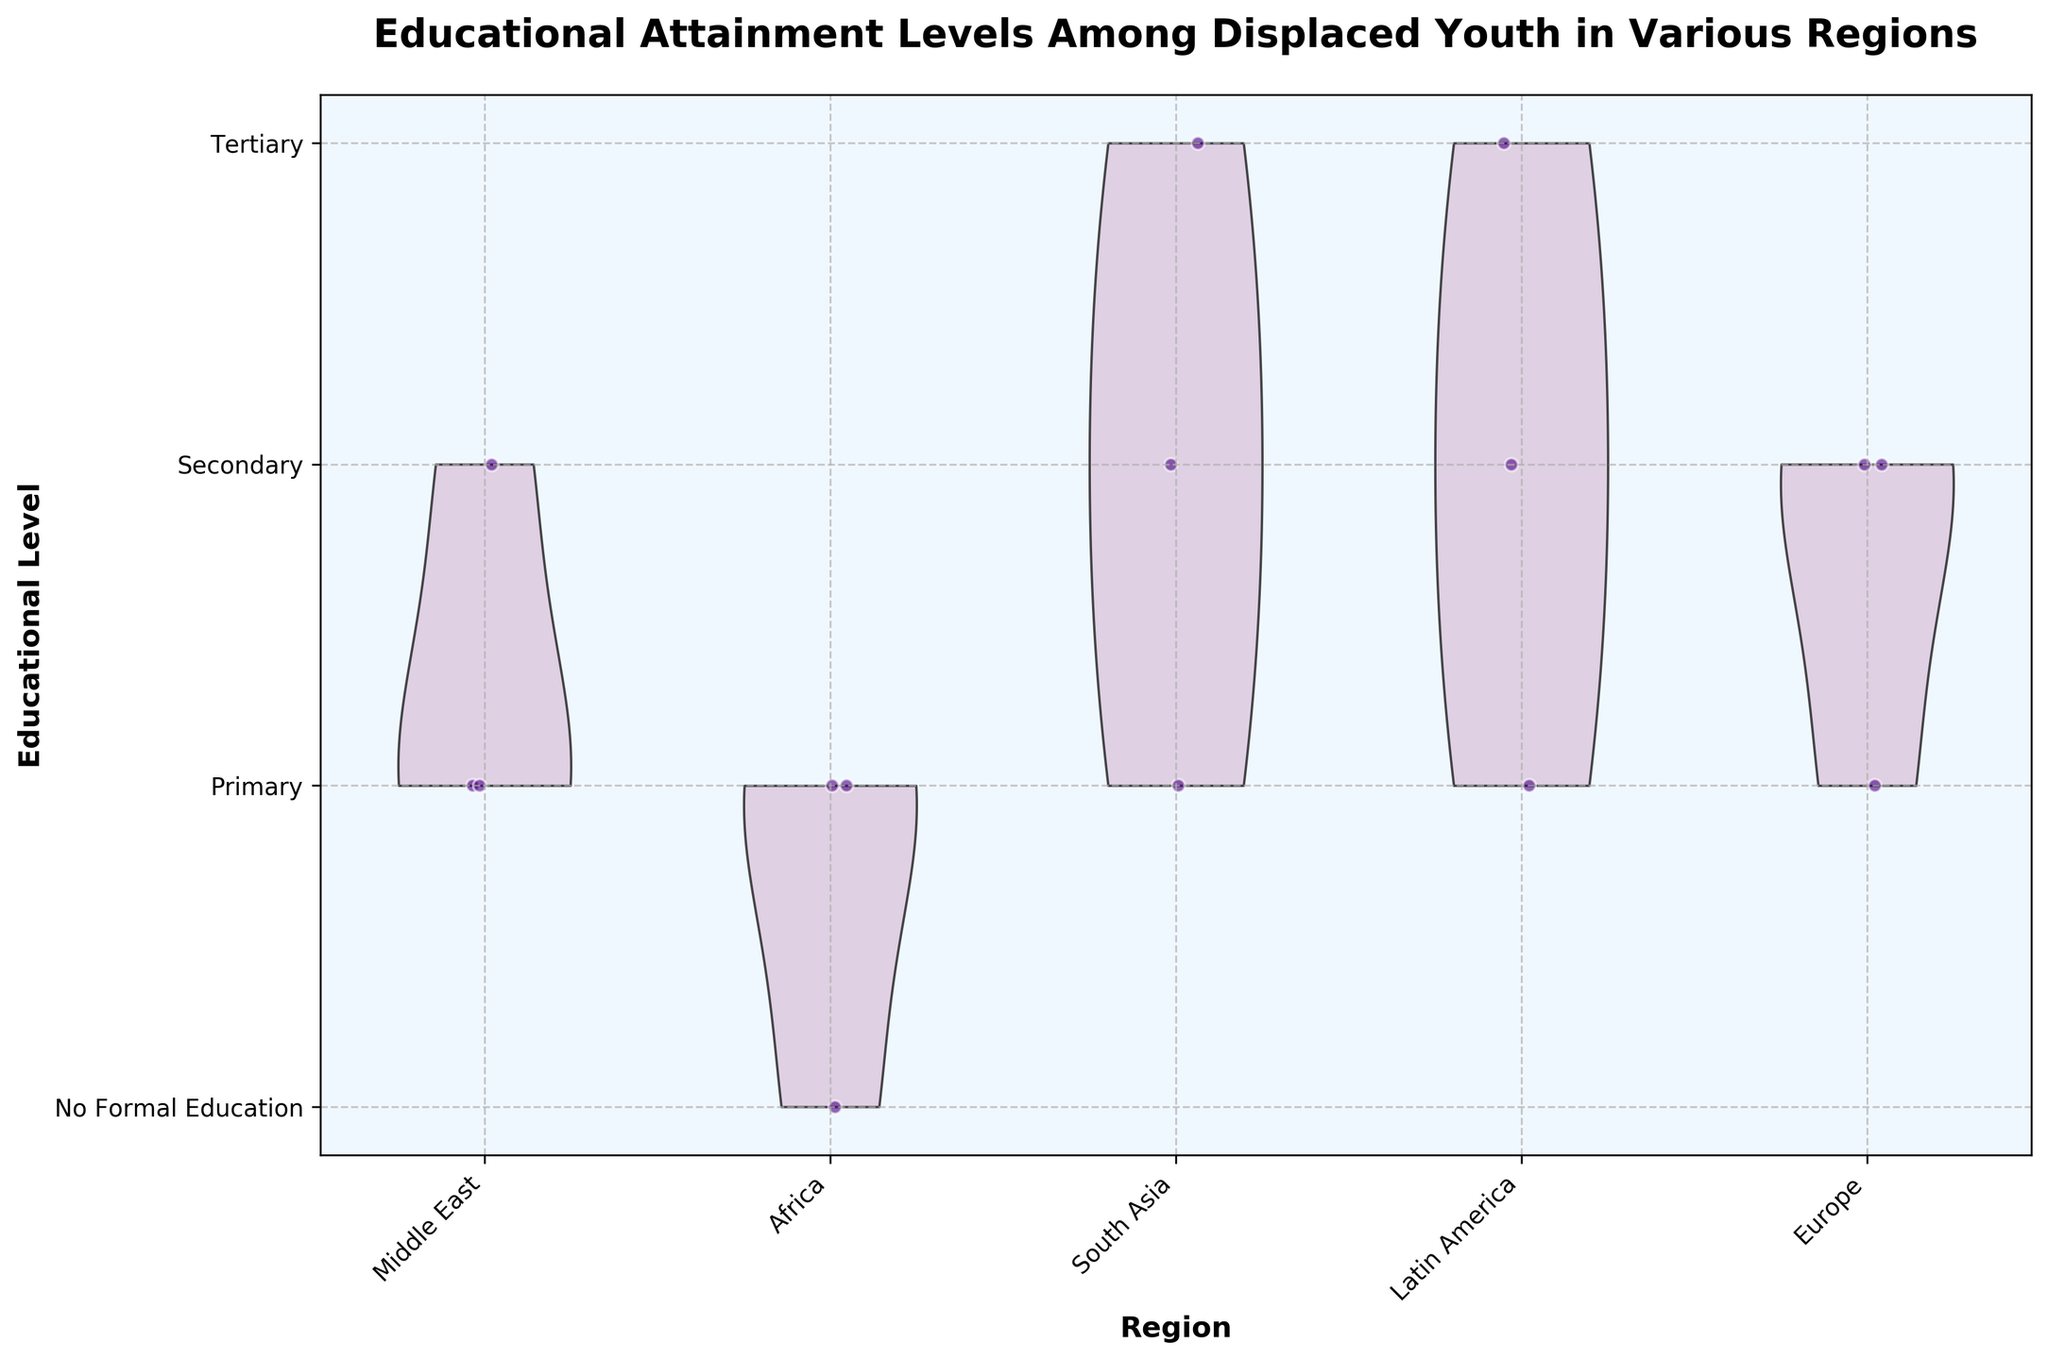What does the figure title indicate? The title "Educational Attainment Levels Among Displaced Youth in Various Regions" indicates that the plot shows the educational levels of displaced youth across several geographic regions.
Answer: Educational Attainment Levels Among Displaced Youth in Various Regions Which regions are compared in the plot? The x-axis labels indicate the regions being compared, which are the Middle East, Africa, South Asia, Latin America, and Europe.
Answer: Middle East, Africa, South Asia, Latin America, Europe How many educational levels are shown on the y-axis? The y-axis labels list the educational levels, which are No Formal Education, Primary, Secondary, and Tertiary. This totals to four educational levels.
Answer: 4 What color are the jittered points in the plot? The scatter points overlaid on the violins are colored in a shade of purple, which provides a visual contrast to the violins.
Answer: Purple Which region has the most youth at the Tertiary level? The jittered points lying at the Tertiary level (y-axis) allow us to observe that South Asia and Latin America both have data points at this level, but without specific counts, we can only confirm both have representation.
Answer: South Asia and Latin America Which region appears to have the least representation in No Formal Education? By inspecting the y-axis and jittered points, it's evident that the Middle East and Latin America show no points at the No Formal Education level.
Answer: Middle East and Latin America Based on the plot, what is the primary educational level for South Sudan? The jittered points for South Sudan dominate the y-axis position of Primary and No Formal Education, suggesting a significant number of youth in these categories.
Answer: Primary and No Formal Education Compare the representation of Secondary education between Syria and Ukraine. By comparing the number of jittered points at the Secondary level between these two regions, Syria appears to have fewer data points than Ukraine at this level.
Answer: Ukraine > Syria What's the median educational level for displaced youth from Afghanistan? Observing the positions of jittered points for Afghanistan, they are spread across Primary, Secondary, and Tertiary levels with the middle value appearing to be Secondary.
Answer: Secondary How are the violin plots and jittered points utilized together in this figure? The violin plots provide a density estimate for educational attainment, showing the distribution shapes, while jittered points offer detailed individual data points and their educational levels.
Answer: Distribution and individual data points 